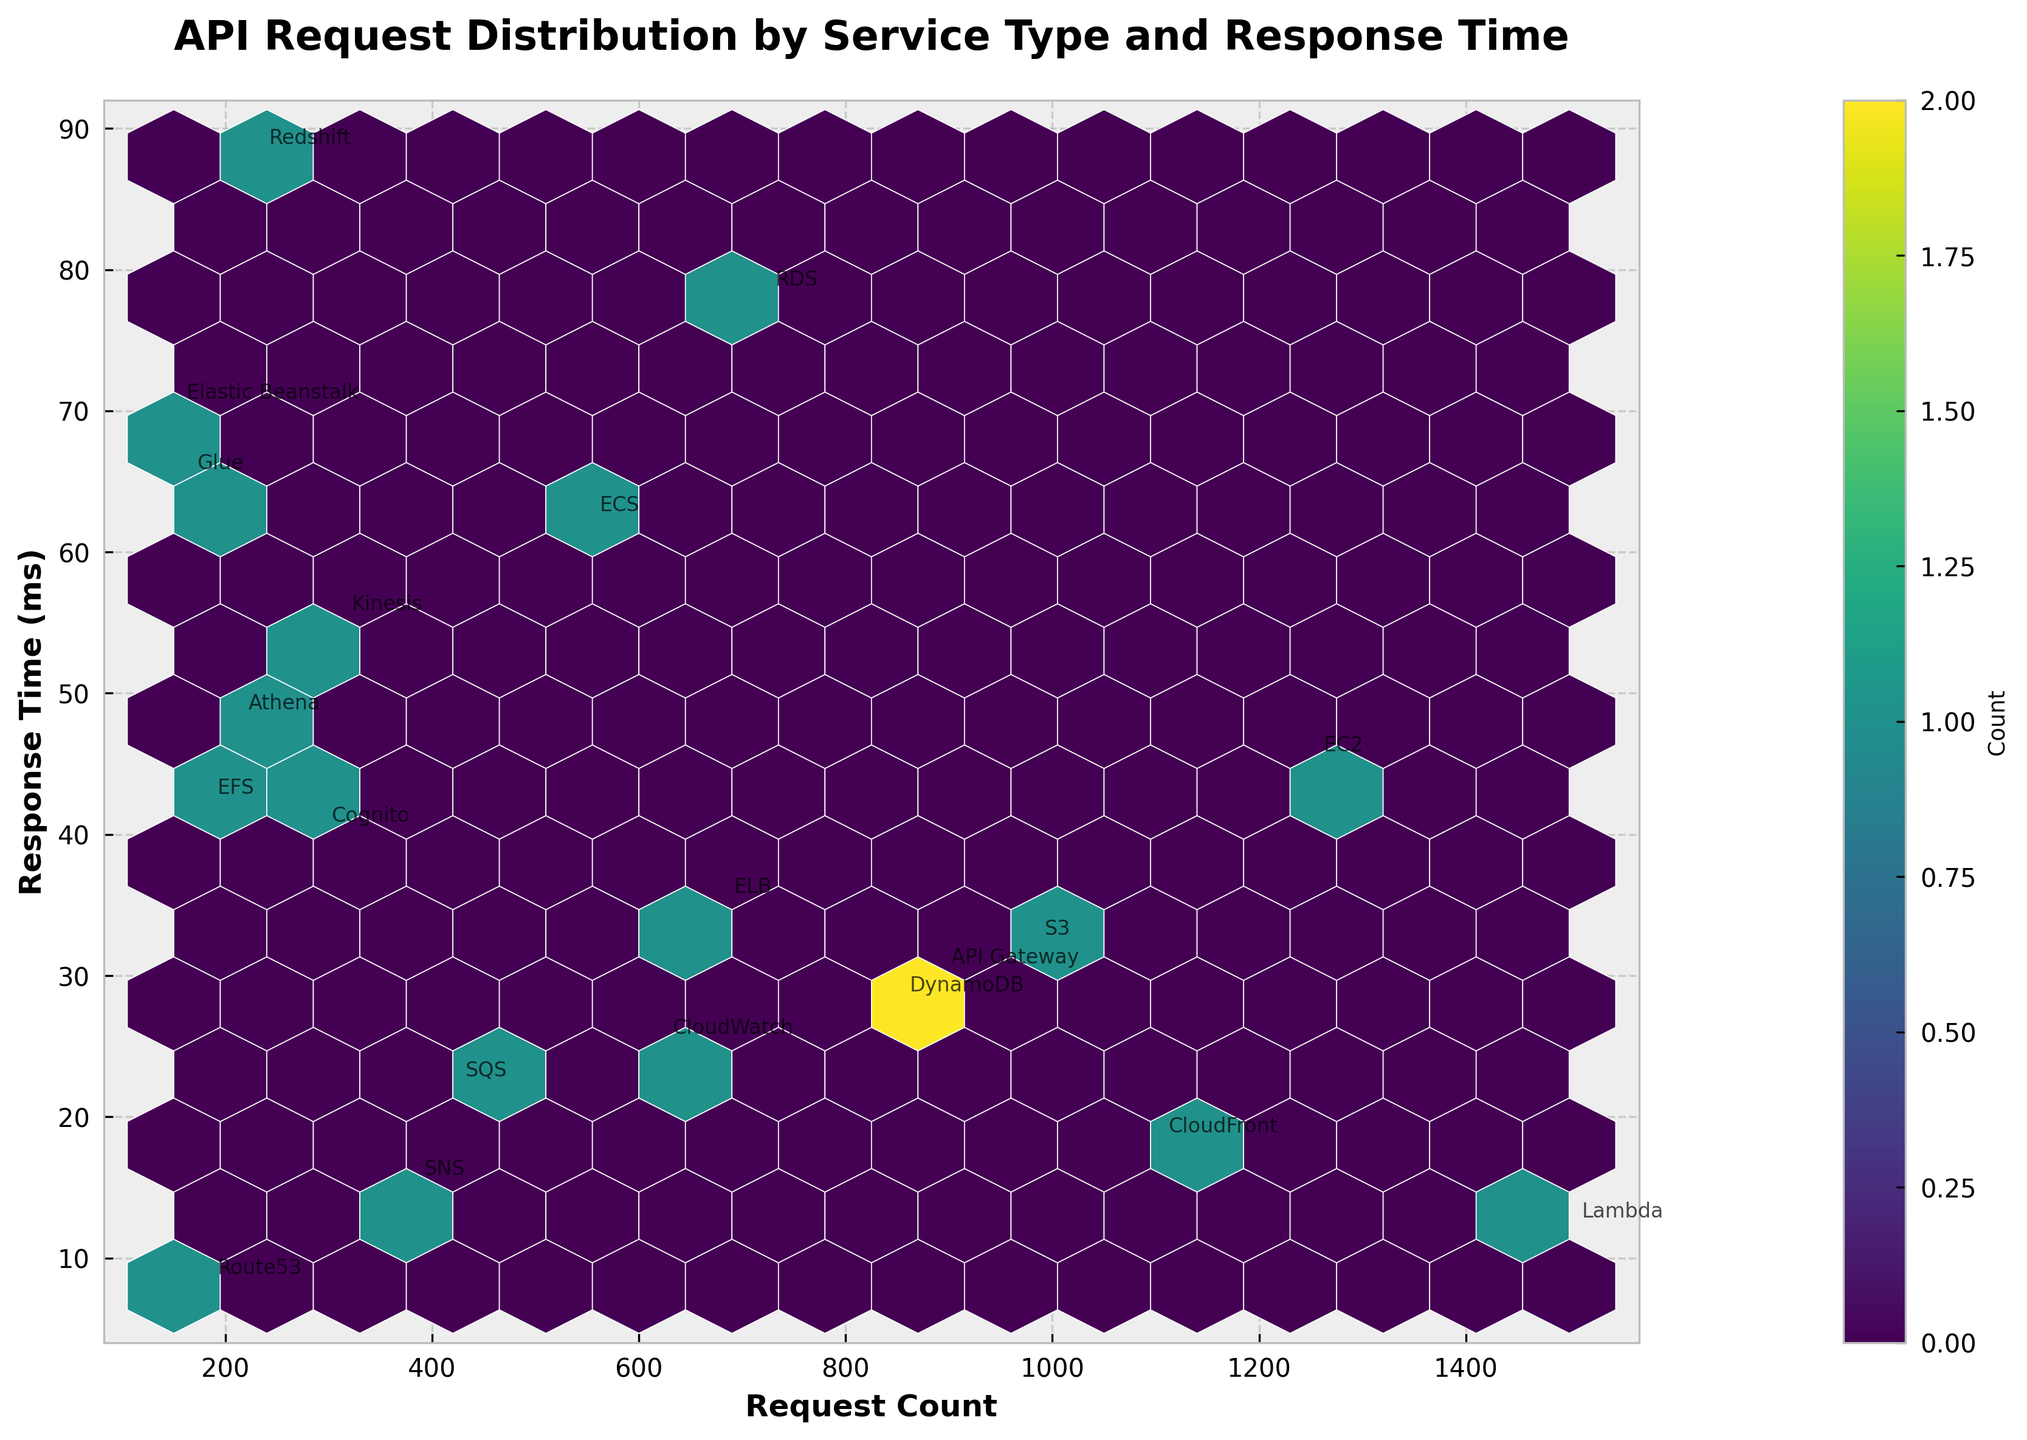What is the title of the Hexbin plot? The title is the text at the top of the figure. In this case, it states the main subject being visualized.
Answer: API Request Distribution by Service Type and Response Time What are the labels of the x-axis and y-axis? The labels are found on the horizontal and vertical axes of the plot, indicating what each axis represents.
Answer: Request Count (x-axis) and Response Time (ms) (y-axis) How many bins contain data points? Look at the hexagonal shapes in the plot and count those filled with colors.
Answer: 12 Which service has the highest request count? Locate the point farthest to the right on the x-axis and check the annotated service name next to that point.
Answer: Lambda How many services have a response time greater than 50 ms? Inspect the y-axis for the 50 ms mark and count the points above this line. Services associated with these points should be annotated.
Answer: 5 Which service has both a request count less than 200 and the shortest response time? Identify the points within the range of less than 200 for request count, then look for the lowest point on the y-axis within this group.
Answer: Route53 Is the count of requests larger for S3 or DynamoDB? Compare the positions of S3 and DynamoDB on the x-axis since the request count is indicated along this axis.
Answer: S3 Which services have a response time under 20 ms and how many are there? Look for points below the 20 ms mark on the y-axis and identify the annotated services associated with these points.
Answer: Lambda, SNS, CloudFront, SQS - 4 services What is the average response time of EC2 and S3 combined? Find the response times for EC2 and S3 annotated points and calculate the average: (45 + 32) / 2.
Answer: 38.5 ms 